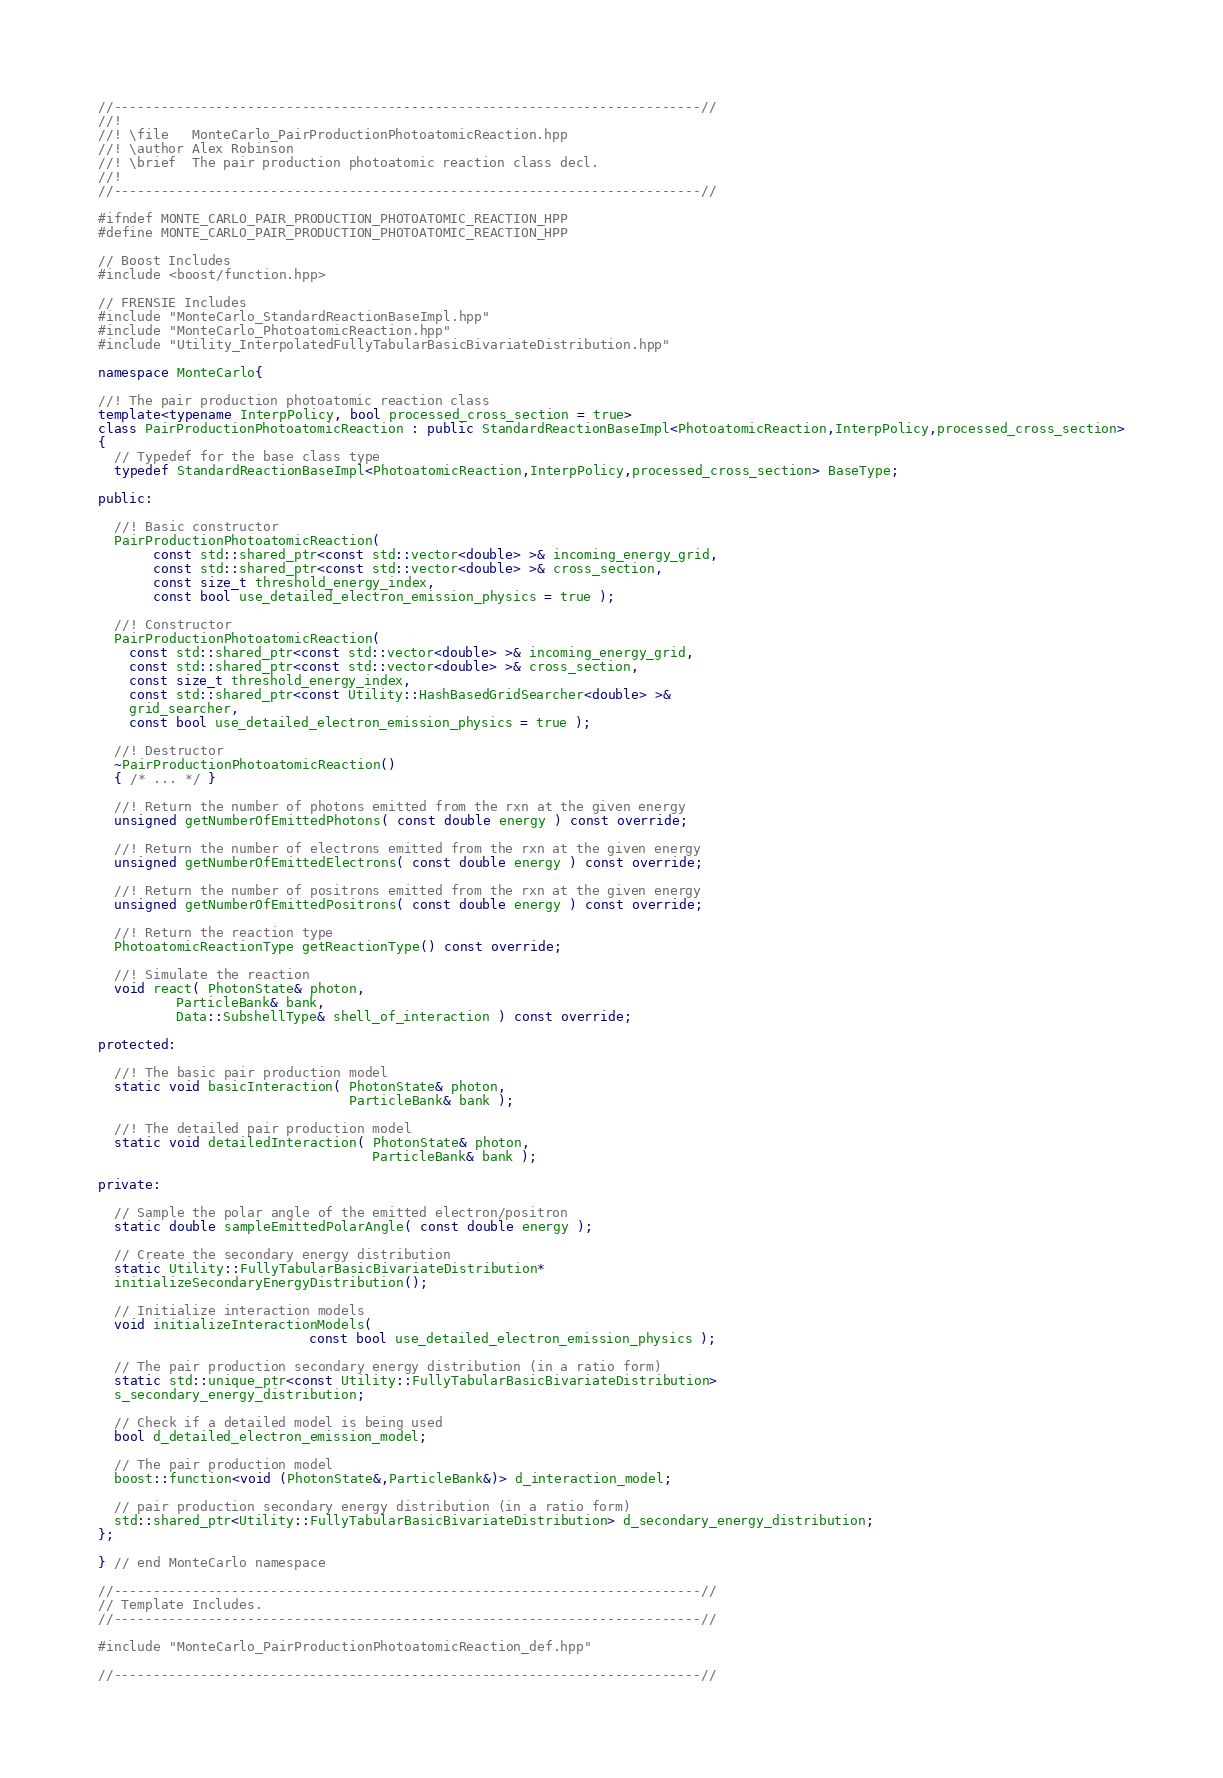<code> <loc_0><loc_0><loc_500><loc_500><_C++_>//---------------------------------------------------------------------------//
//!
//! \file   MonteCarlo_PairProductionPhotoatomicReaction.hpp
//! \author Alex Robinson
//! \brief  The pair production photoatomic reaction class decl.
//!
//---------------------------------------------------------------------------//

#ifndef MONTE_CARLO_PAIR_PRODUCTION_PHOTOATOMIC_REACTION_HPP
#define MONTE_CARLO_PAIR_PRODUCTION_PHOTOATOMIC_REACTION_HPP

// Boost Includes
#include <boost/function.hpp>

// FRENSIE Includes
#include "MonteCarlo_StandardReactionBaseImpl.hpp"
#include "MonteCarlo_PhotoatomicReaction.hpp"
#include "Utility_InterpolatedFullyTabularBasicBivariateDistribution.hpp"

namespace MonteCarlo{

//! The pair production photoatomic reaction class
template<typename InterpPolicy, bool processed_cross_section = true>
class PairProductionPhotoatomicReaction : public StandardReactionBaseImpl<PhotoatomicReaction,InterpPolicy,processed_cross_section>
{
  // Typedef for the base class type
  typedef StandardReactionBaseImpl<PhotoatomicReaction,InterpPolicy,processed_cross_section> BaseType;

public:

  //! Basic constructor
  PairProductionPhotoatomicReaction(
       const std::shared_ptr<const std::vector<double> >& incoming_energy_grid,
       const std::shared_ptr<const std::vector<double> >& cross_section,
       const size_t threshold_energy_index,
       const bool use_detailed_electron_emission_physics = true );

  //! Constructor
  PairProductionPhotoatomicReaction(
    const std::shared_ptr<const std::vector<double> >& incoming_energy_grid,
    const std::shared_ptr<const std::vector<double> >& cross_section,
    const size_t threshold_energy_index,
    const std::shared_ptr<const Utility::HashBasedGridSearcher<double> >&
    grid_searcher,
    const bool use_detailed_electron_emission_physics = true );

  //! Destructor
  ~PairProductionPhotoatomicReaction()
  { /* ... */ }

  //! Return the number of photons emitted from the rxn at the given energy
  unsigned getNumberOfEmittedPhotons( const double energy ) const override;

  //! Return the number of electrons emitted from the rxn at the given energy
  unsigned getNumberOfEmittedElectrons( const double energy ) const override;

  //! Return the number of positrons emitted from the rxn at the given energy
  unsigned getNumberOfEmittedPositrons( const double energy ) const override;

  //! Return the reaction type
  PhotoatomicReactionType getReactionType() const override;

  //! Simulate the reaction
  void react( PhotonState& photon,
	      ParticleBank& bank,
	      Data::SubshellType& shell_of_interaction ) const override;

protected:

  //! The basic pair production model
  static void basicInteraction( PhotonState& photon,
                                ParticleBank& bank );

  //! The detailed pair production model
  static void detailedInteraction( PhotonState& photon,
                                   ParticleBank& bank );

private:

  // Sample the polar angle of the emitted electron/positron
  static double sampleEmittedPolarAngle( const double energy );

  // Create the secondary energy distribution
  static Utility::FullyTabularBasicBivariateDistribution*
  initializeSecondaryEnergyDistribution();

  // Initialize interaction models
  void initializeInteractionModels(
                           const bool use_detailed_electron_emission_physics );

  // The pair production secondary energy distribution (in a ratio form)
  static std::unique_ptr<const Utility::FullyTabularBasicBivariateDistribution>
  s_secondary_energy_distribution;

  // Check if a detailed model is being used
  bool d_detailed_electron_emission_model;

  // The pair production model
  boost::function<void (PhotonState&,ParticleBank&)> d_interaction_model;

  // pair production secondary energy distribution (in a ratio form)
  std::shared_ptr<Utility::FullyTabularBasicBivariateDistribution> d_secondary_energy_distribution;
};

} // end MonteCarlo namespace

//---------------------------------------------------------------------------//
// Template Includes.
//---------------------------------------------------------------------------//

#include "MonteCarlo_PairProductionPhotoatomicReaction_def.hpp"

//---------------------------------------------------------------------------//
</code> 